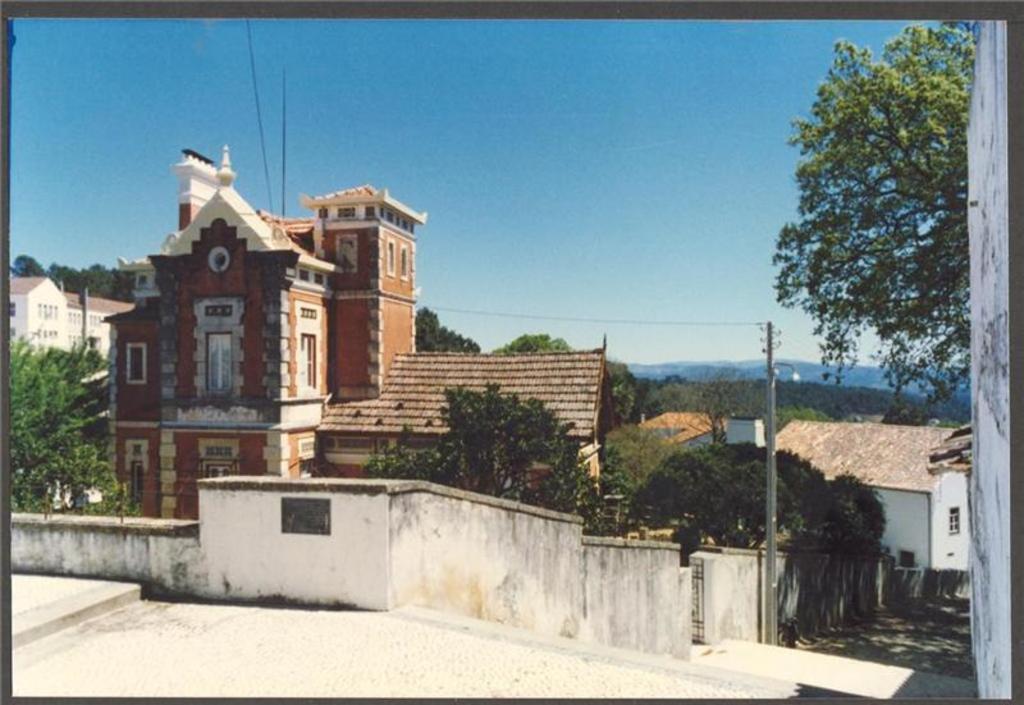In one or two sentences, can you explain what this image depicts? This looks like a current pole. These are the buildings with windows. I can see the trees. I think these are the stairs. This is the wall. 